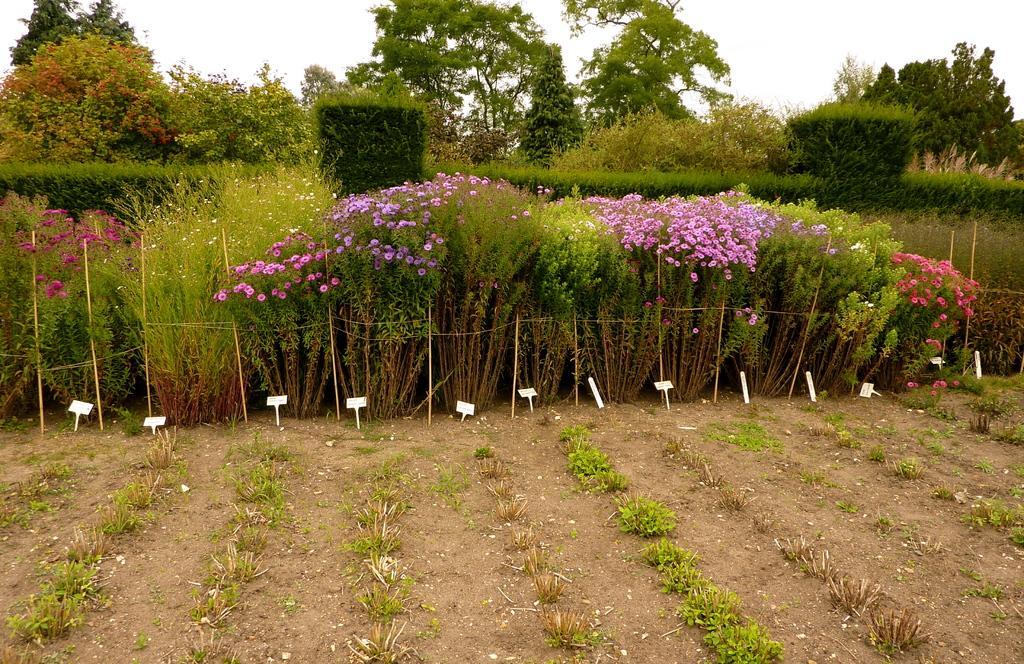In one or two sentences, can you explain what this image depicts? In this image we can see group of flowers on plants. In the foreground we can see some sticks and boards placed on the ground. In the background, we can see a group of trees and the sky. 